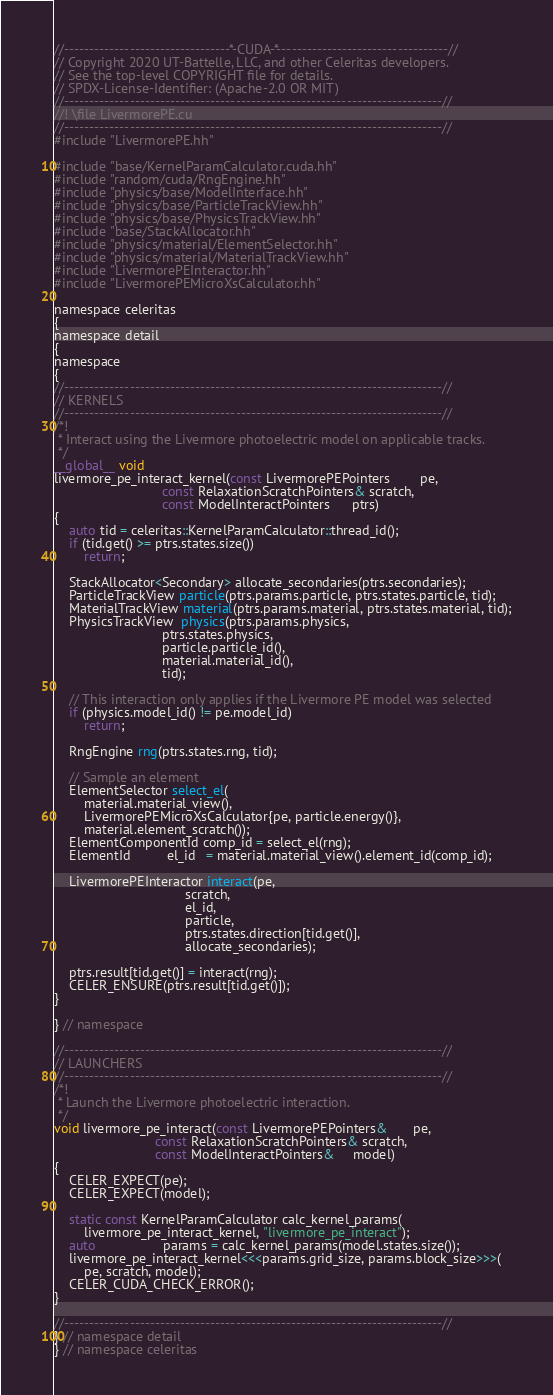Convert code to text. <code><loc_0><loc_0><loc_500><loc_500><_Cuda_>//---------------------------------*-CUDA-*----------------------------------//
// Copyright 2020 UT-Battelle, LLC, and other Celeritas developers.
// See the top-level COPYRIGHT file for details.
// SPDX-License-Identifier: (Apache-2.0 OR MIT)
//---------------------------------------------------------------------------//
//! \file LivermorePE.cu
//---------------------------------------------------------------------------//
#include "LivermorePE.hh"

#include "base/KernelParamCalculator.cuda.hh"
#include "random/cuda/RngEngine.hh"
#include "physics/base/ModelInterface.hh"
#include "physics/base/ParticleTrackView.hh"
#include "physics/base/PhysicsTrackView.hh"
#include "base/StackAllocator.hh"
#include "physics/material/ElementSelector.hh"
#include "physics/material/MaterialTrackView.hh"
#include "LivermorePEInteractor.hh"
#include "LivermorePEMicroXsCalculator.hh"

namespace celeritas
{
namespace detail
{
namespace
{
//---------------------------------------------------------------------------//
// KERNELS
//---------------------------------------------------------------------------//
/*!
 * Interact using the Livermore photoelectric model on applicable tracks.
 */
__global__ void
livermore_pe_interact_kernel(const LivermorePEPointers        pe,
                             const RelaxationScratchPointers& scratch,
                             const ModelInteractPointers      ptrs)
{
    auto tid = celeritas::KernelParamCalculator::thread_id();
    if (tid.get() >= ptrs.states.size())
        return;

    StackAllocator<Secondary> allocate_secondaries(ptrs.secondaries);
    ParticleTrackView particle(ptrs.params.particle, ptrs.states.particle, tid);
    MaterialTrackView material(ptrs.params.material, ptrs.states.material, tid);
    PhysicsTrackView  physics(ptrs.params.physics,
                             ptrs.states.physics,
                             particle.particle_id(),
                             material.material_id(),
                             tid);

    // This interaction only applies if the Livermore PE model was selected
    if (physics.model_id() != pe.model_id)
        return;

    RngEngine rng(ptrs.states.rng, tid);

    // Sample an element
    ElementSelector select_el(
        material.material_view(),
        LivermorePEMicroXsCalculator{pe, particle.energy()},
        material.element_scratch());
    ElementComponentId comp_id = select_el(rng);
    ElementId          el_id   = material.material_view().element_id(comp_id);

    LivermorePEInteractor interact(pe,
                                   scratch,
                                   el_id,
                                   particle,
                                   ptrs.states.direction[tid.get()],
                                   allocate_secondaries);

    ptrs.result[tid.get()] = interact(rng);
    CELER_ENSURE(ptrs.result[tid.get()]);
}

} // namespace

//---------------------------------------------------------------------------//
// LAUNCHERS
//---------------------------------------------------------------------------//
/*!
 * Launch the Livermore photoelectric interaction.
 */
void livermore_pe_interact(const LivermorePEPointers&       pe,
                           const RelaxationScratchPointers& scratch,
                           const ModelInteractPointers&     model)
{
    CELER_EXPECT(pe);
    CELER_EXPECT(model);

    static const KernelParamCalculator calc_kernel_params(
        livermore_pe_interact_kernel, "livermore_pe_interact");
    auto                  params = calc_kernel_params(model.states.size());
    livermore_pe_interact_kernel<<<params.grid_size, params.block_size>>>(
        pe, scratch, model);
    CELER_CUDA_CHECK_ERROR();
}

//---------------------------------------------------------------------------//
} // namespace detail
} // namespace celeritas
</code> 